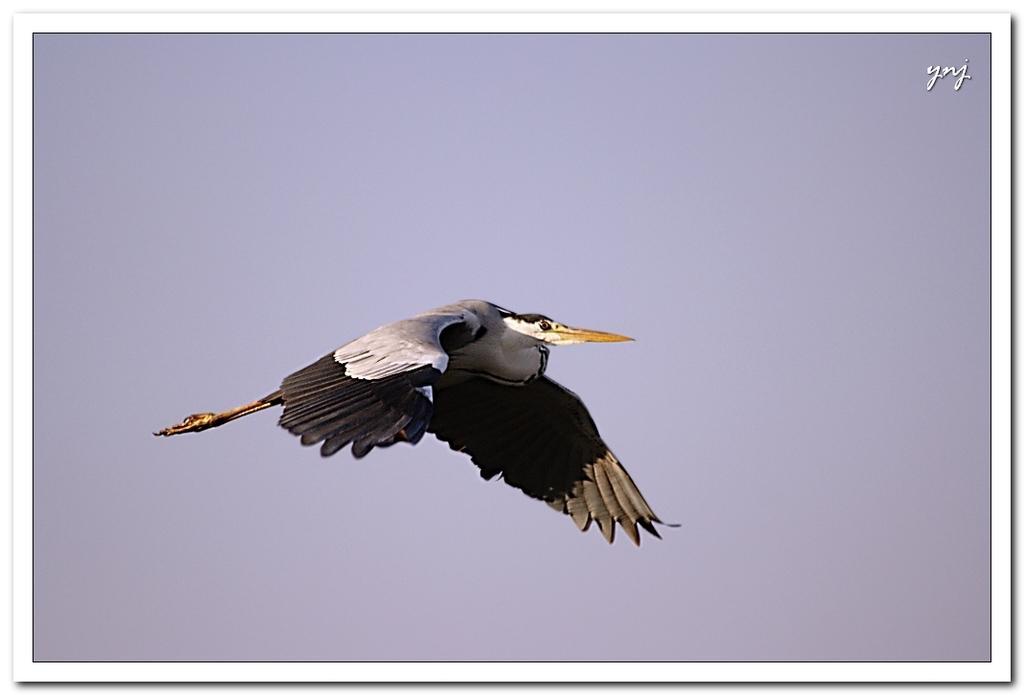In one or two sentences, can you explain what this image depicts? In this image I can see the bird and the bird is in white and brown color. In the background I can see the sky in white color. 